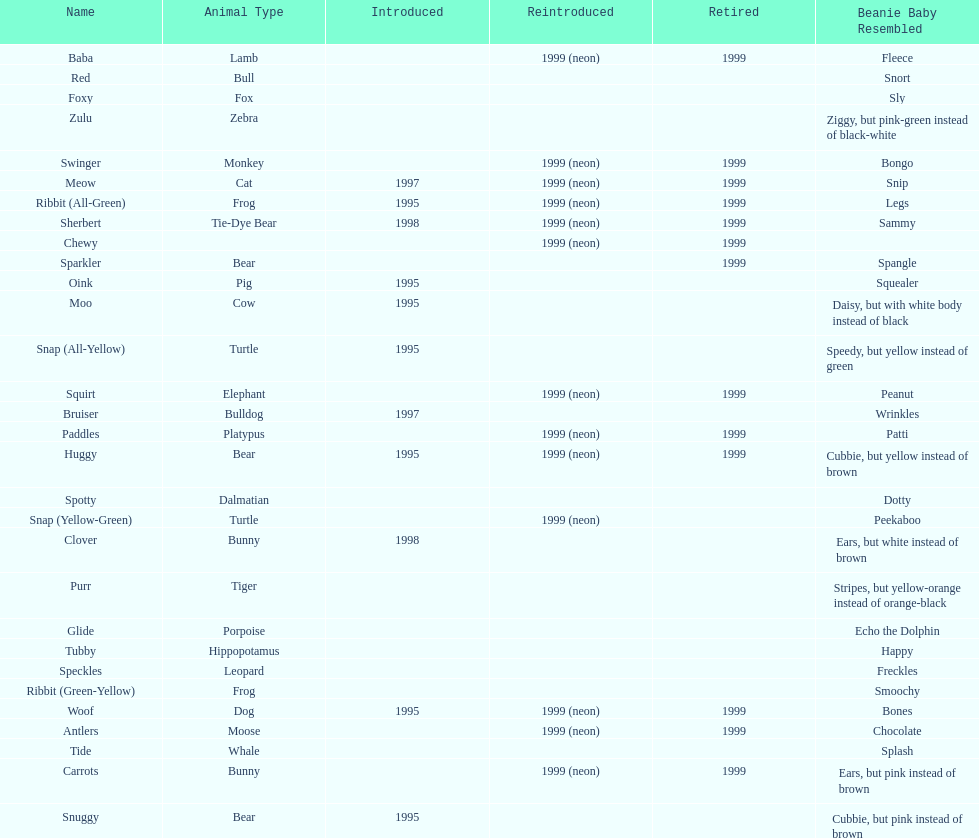Can you give me this table as a dict? {'header': ['Name', 'Animal Type', 'Introduced', 'Reintroduced', 'Retired', 'Beanie Baby Resembled'], 'rows': [['Baba', 'Lamb', '', '1999 (neon)', '1999', 'Fleece'], ['Red', 'Bull', '', '', '', 'Snort'], ['Foxy', 'Fox', '', '', '', 'Sly'], ['Zulu', 'Zebra', '', '', '', 'Ziggy, but pink-green instead of black-white'], ['Swinger', 'Monkey', '', '1999 (neon)', '1999', 'Bongo'], ['Meow', 'Cat', '1997', '1999 (neon)', '1999', 'Snip'], ['Ribbit (All-Green)', 'Frog', '1995', '1999 (neon)', '1999', 'Legs'], ['Sherbert', 'Tie-Dye Bear', '1998', '1999 (neon)', '1999', 'Sammy'], ['Chewy', '', '', '1999 (neon)', '1999', ''], ['Sparkler', 'Bear', '', '', '1999', 'Spangle'], ['Oink', 'Pig', '1995', '', '', 'Squealer'], ['Moo', 'Cow', '1995', '', '', 'Daisy, but with white body instead of black'], ['Snap (All-Yellow)', 'Turtle', '1995', '', '', 'Speedy, but yellow instead of green'], ['Squirt', 'Elephant', '', '1999 (neon)', '1999', 'Peanut'], ['Bruiser', 'Bulldog', '1997', '', '', 'Wrinkles'], ['Paddles', 'Platypus', '', '1999 (neon)', '1999', 'Patti'], ['Huggy', 'Bear', '1995', '1999 (neon)', '1999', 'Cubbie, but yellow instead of brown'], ['Spotty', 'Dalmatian', '', '', '', 'Dotty'], ['Snap (Yellow-Green)', 'Turtle', '', '1999 (neon)', '', 'Peekaboo'], ['Clover', 'Bunny', '1998', '', '', 'Ears, but white instead of brown'], ['Purr', 'Tiger', '', '', '', 'Stripes, but yellow-orange instead of orange-black'], ['Glide', 'Porpoise', '', '', '', 'Echo the Dolphin'], ['Tubby', 'Hippopotamus', '', '', '', 'Happy'], ['Speckles', 'Leopard', '', '', '', 'Freckles'], ['Ribbit (Green-Yellow)', 'Frog', '', '', '', 'Smoochy'], ['Woof', 'Dog', '1995', '1999 (neon)', '1999', 'Bones'], ['Antlers', 'Moose', '', '1999 (neon)', '1999', 'Chocolate'], ['Tide', 'Whale', '', '', '', 'Splash'], ['Carrots', 'Bunny', '', '1999 (neon)', '1999', 'Ears, but pink instead of brown'], ['Snuggy', 'Bear', '1995', '', '', 'Cubbie, but pink instead of brown']]} What is the total number of pillow pals that were reintroduced as a neon variety? 13. 